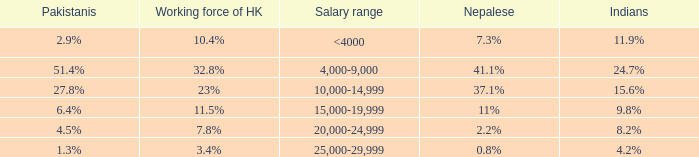If the Indians are 8.2%, what is the salary range? 20,000-24,999. 